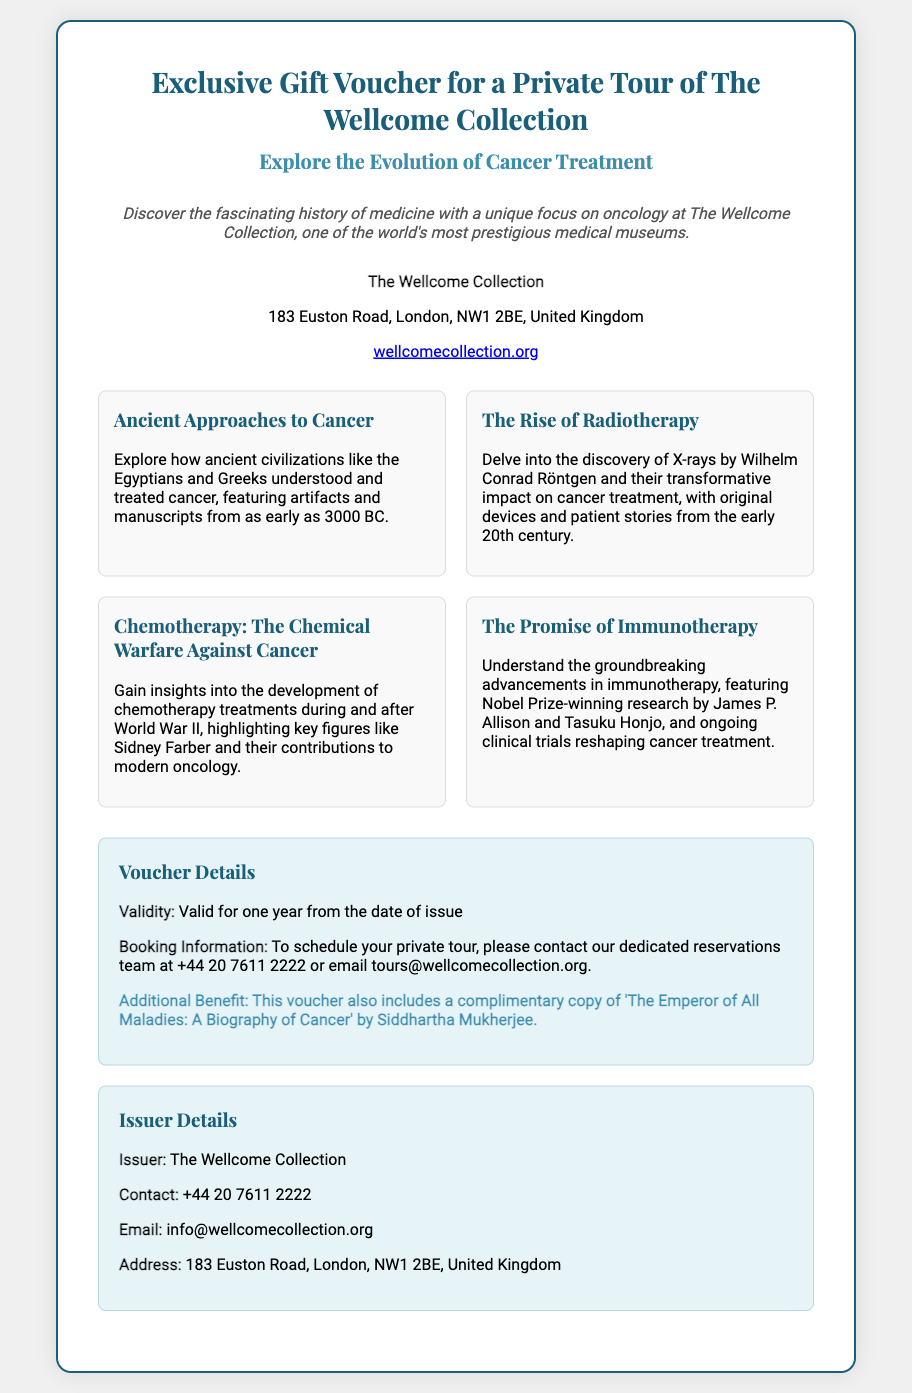What is the name of the museum featured in the voucher? The museum is specifically mentioned as The Wellcome Collection in the document.
Answer: The Wellcome Collection What is the address of The Wellcome Collection? The address is given in the document as part of the museum details.
Answer: 183 Euston Road, London, NW1 2BE, United Kingdom What type of tour is offered by the voucher? The document specifies that the voucher is for a private tour of the museum.
Answer: Private tour What additional benefit is included with the voucher? The document states that a complimentary copy of a book is included as an additional benefit.
Answer: 'The Emperor of All Maladies: A Biography of Cancer' What is the validity period of the voucher? The document clearly mentions the validity time frame for the voucher.
Answer: One year Who is the issuer of the voucher? The issuer of the voucher is mentioned in the issuer details section of the document.
Answer: The Wellcome Collection How can one schedule the private tour? The document provides specific contact information to arrange the tour.
Answer: Contact our dedicated reservations team What are the highlights featured in the museum? The document describes several exhibits which highlight the evolution of cancer treatment.
Answer: Ancient Approaches to Cancer, The Rise of Radiotherapy, Chemotherapy: The Chemical Warfare Against Cancer, The Promise of Immunotherapy What is the contact number provided for the issuer? The issuer’s contact number is included in the document for inquiries.
Answer: +44 20 7611 2222 